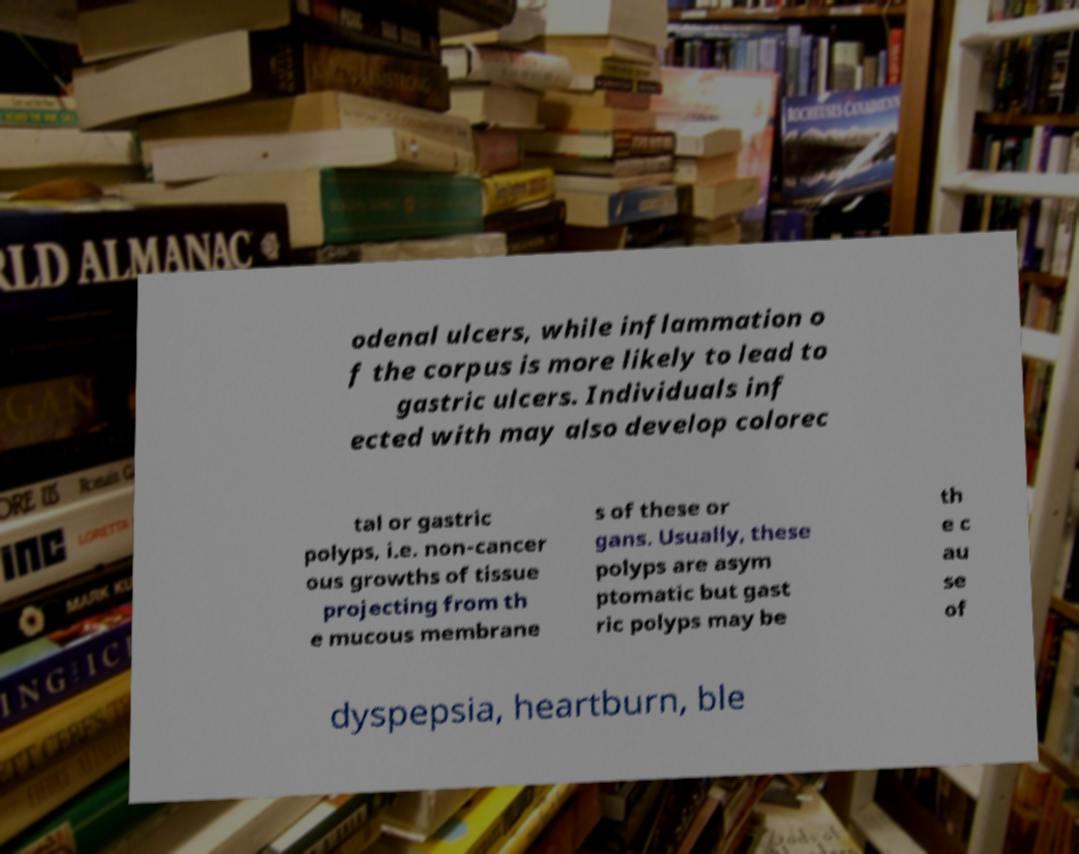Can you read and provide the text displayed in the image?This photo seems to have some interesting text. Can you extract and type it out for me? odenal ulcers, while inflammation o f the corpus is more likely to lead to gastric ulcers. Individuals inf ected with may also develop colorec tal or gastric polyps, i.e. non-cancer ous growths of tissue projecting from th e mucous membrane s of these or gans. Usually, these polyps are asym ptomatic but gast ric polyps may be th e c au se of dyspepsia, heartburn, ble 